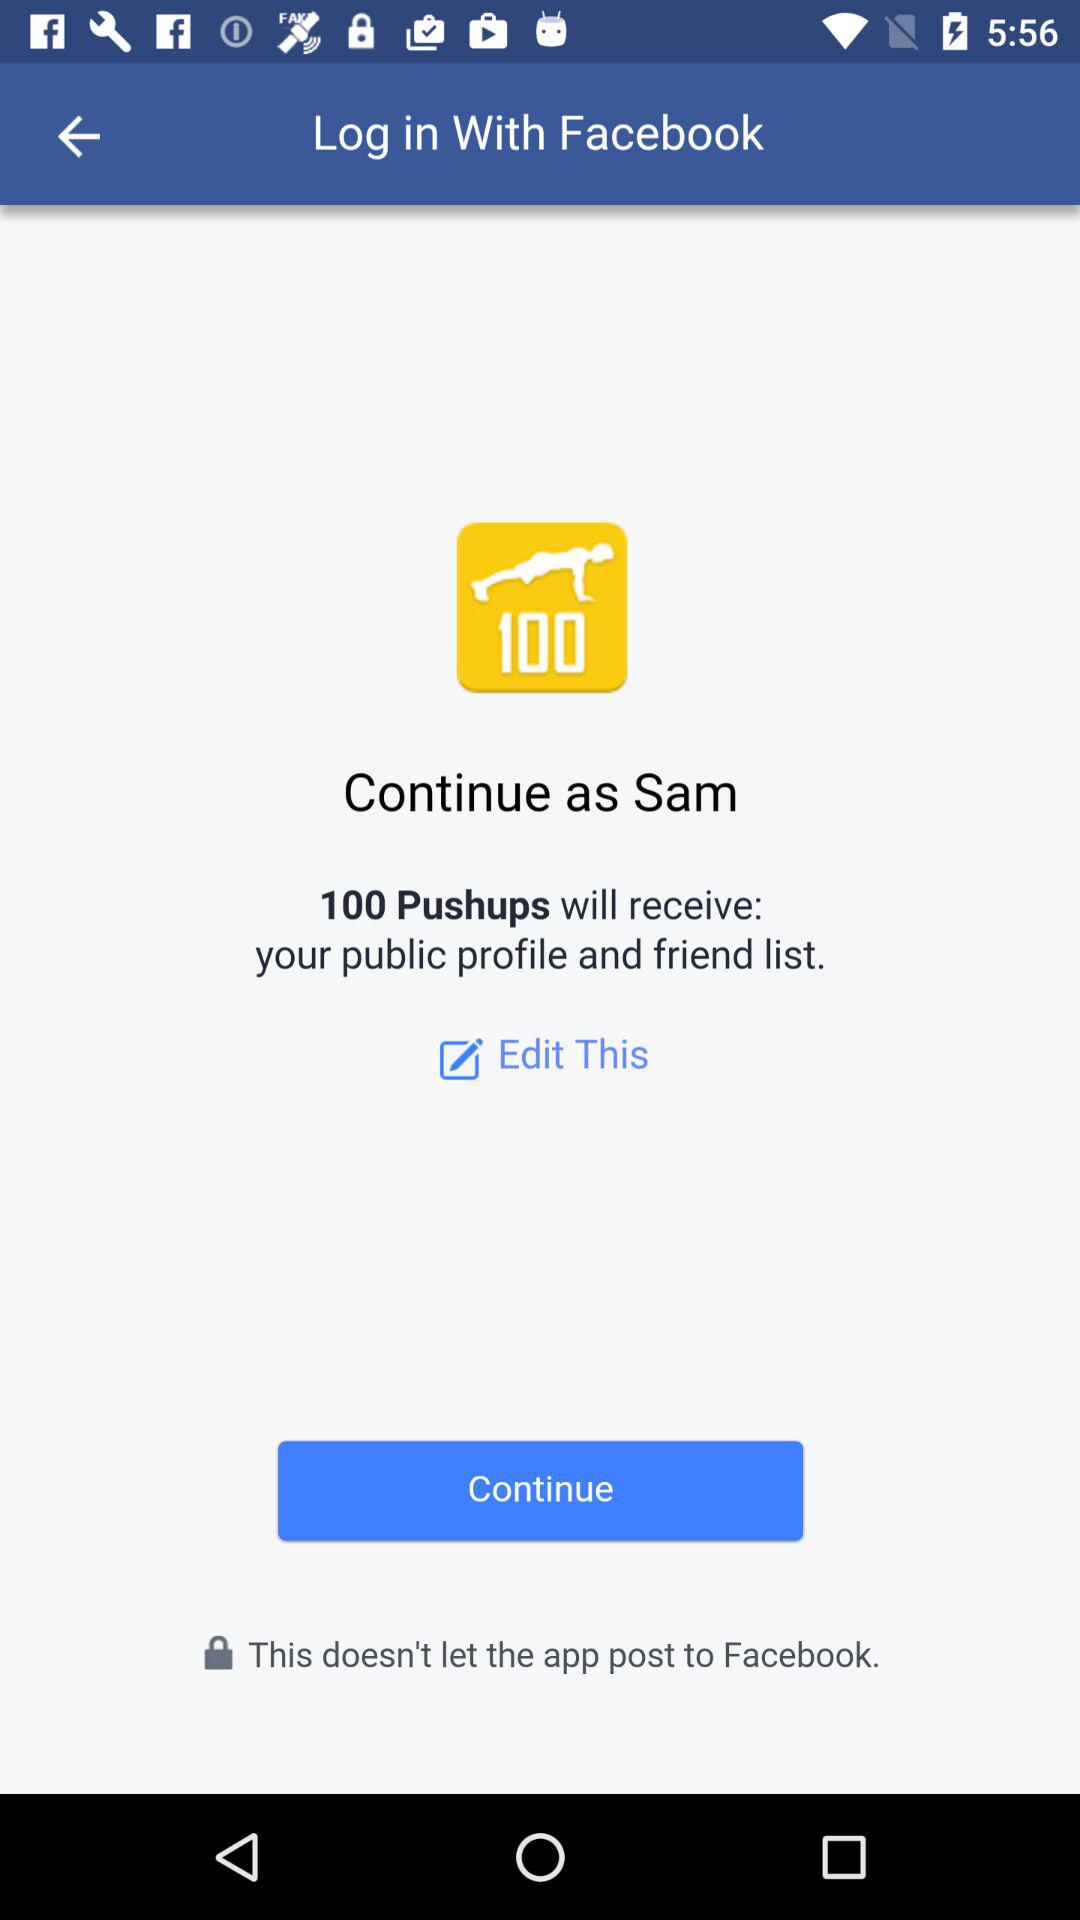Through what application can the user log in? The user can log in through "Facebook". 